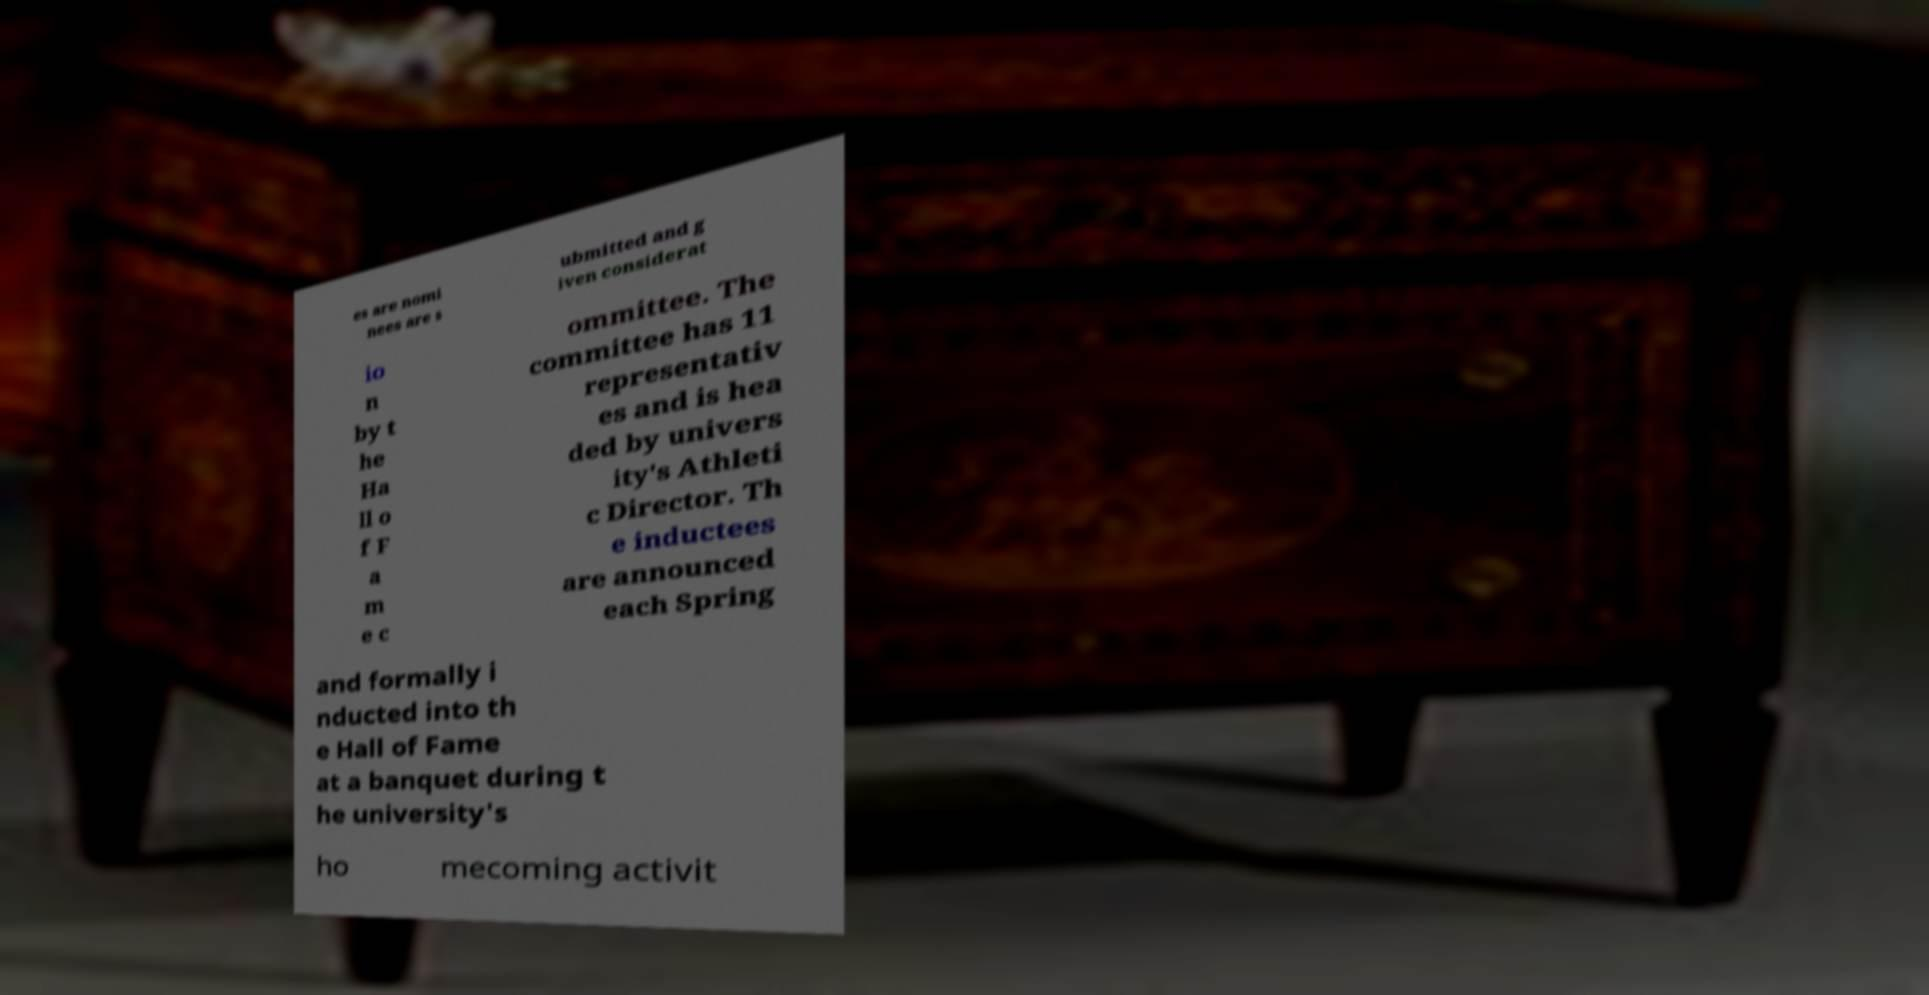Could you extract and type out the text from this image? es are nomi nees are s ubmitted and g iven considerat io n by t he Ha ll o f F a m e c ommittee. The committee has 11 representativ es and is hea ded by univers ity's Athleti c Director. Th e inductees are announced each Spring and formally i nducted into th e Hall of Fame at a banquet during t he university's ho mecoming activit 